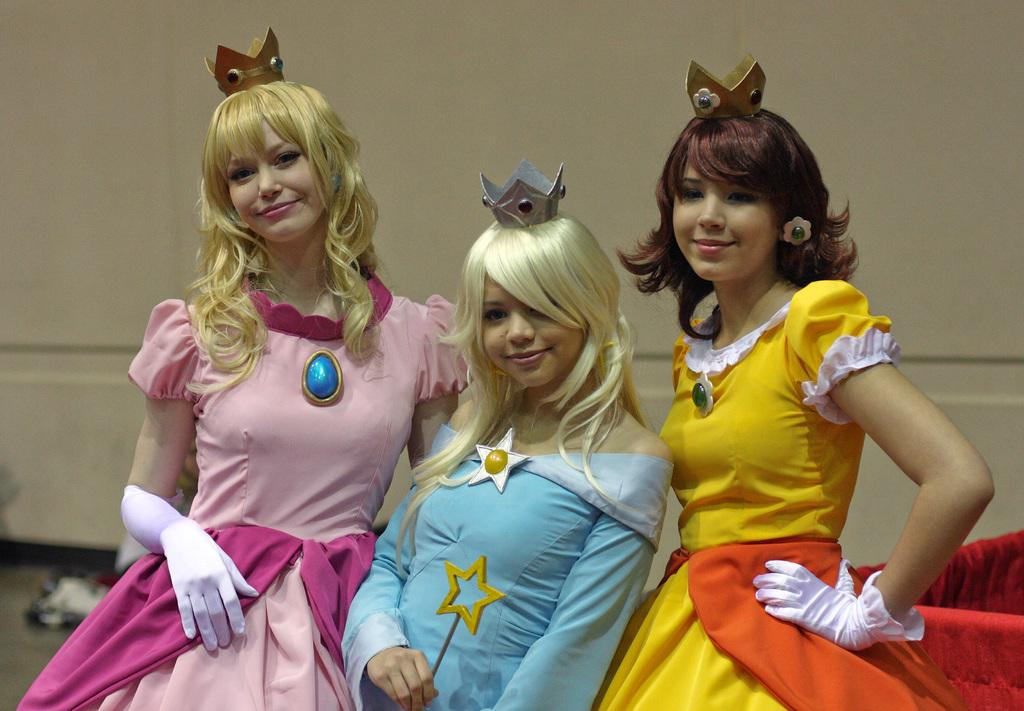How many people are in the front of the image? There are three people standing in the front of the image. What are the people doing in the image? The people are smiling in the image. What are the people wearing on their heads? The people are wearing crowns in the image. What can be seen in the background of the image? There is a wall and objects in the background of the image. Which person's knee is injured in the image? There is no indication of an injured knee in the image. How old is the son of the person in the middle in the image? There is no son present in the image. 